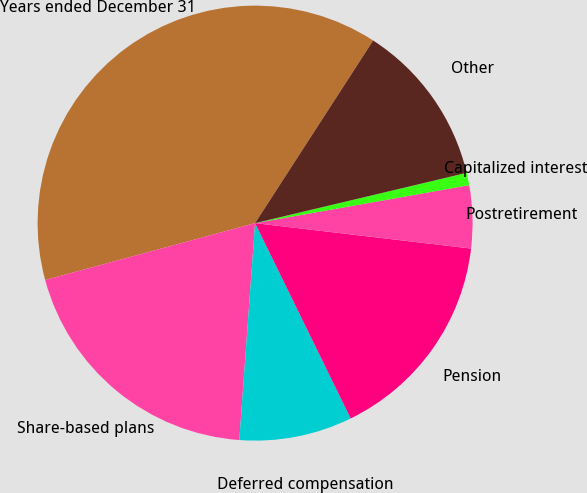Convert chart to OTSL. <chart><loc_0><loc_0><loc_500><loc_500><pie_chart><fcel>Years ended December 31<fcel>Share-based plans<fcel>Deferred compensation<fcel>Pension<fcel>Postretirement<fcel>Capitalized interest<fcel>Other<nl><fcel>38.35%<fcel>19.63%<fcel>8.4%<fcel>15.89%<fcel>4.66%<fcel>0.92%<fcel>12.15%<nl></chart> 